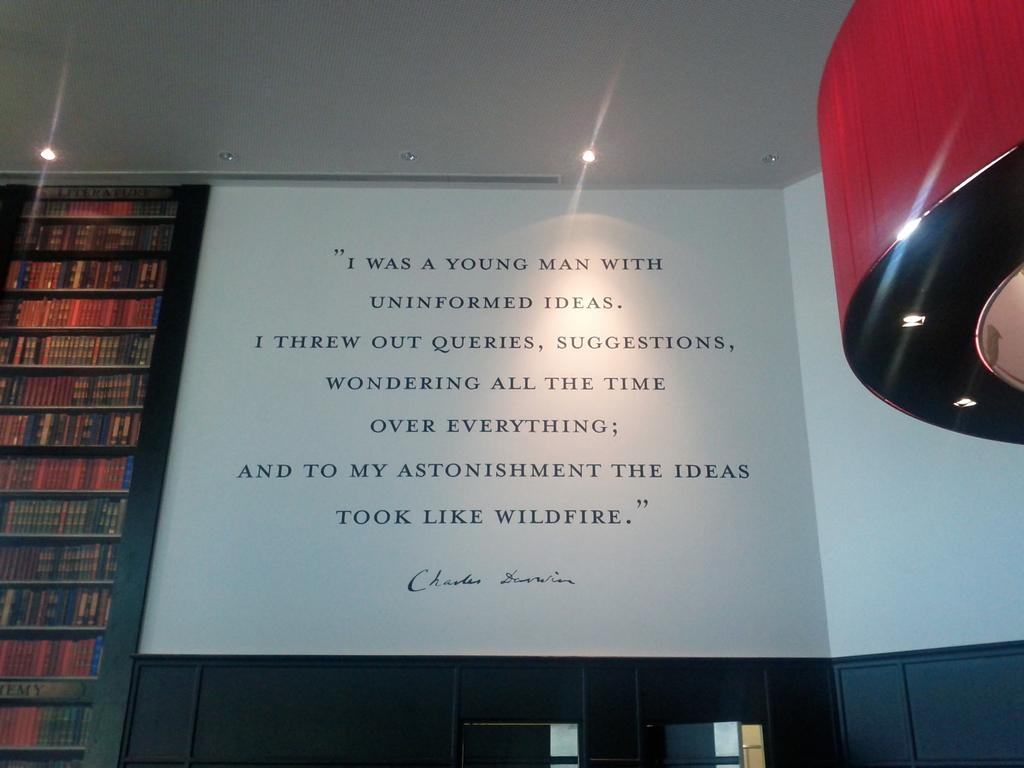Provide a one-sentence caption for the provided image. A Charles Darwin quote is displayed on a wall next to shelves of books. 